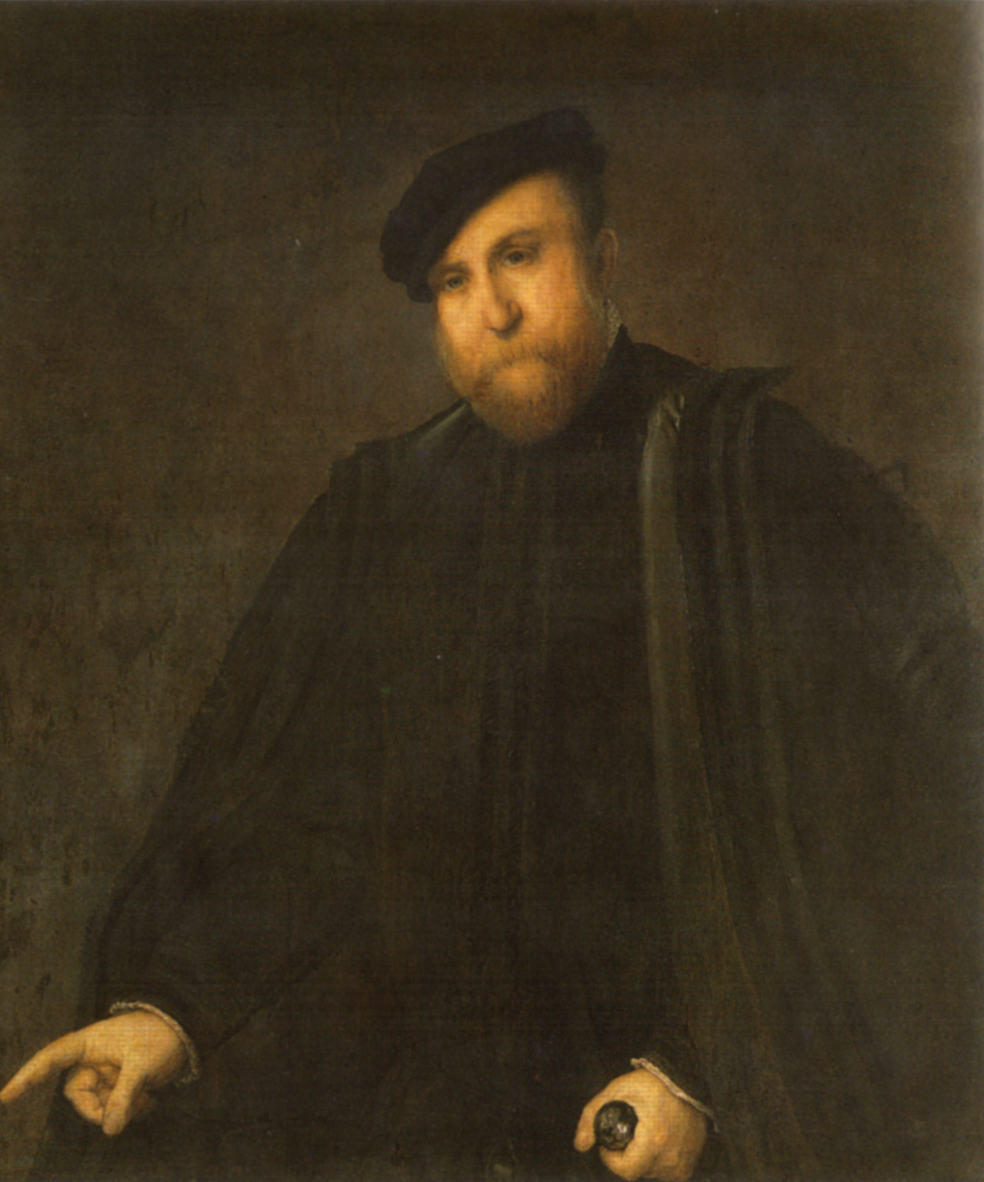Can you explain the artist's approach to lighting and its effect on the mood of the painting? The artist employs a subtle yet powerful use of lighting that focuses mainly on the face and hands of the subject, leaving much of the surrounding details in shadow. This technique, known as chiaroscuro, is instrumental in creating a dramatic and introspective mood, drawing the viewer’s attention to the expressions and the finer details of the subject’s dignity and reflective state. The subdued lighting enhances the overall solemn and contemplative atmosphere, allowing the subject's inner life and character to permeate through the portrait. 